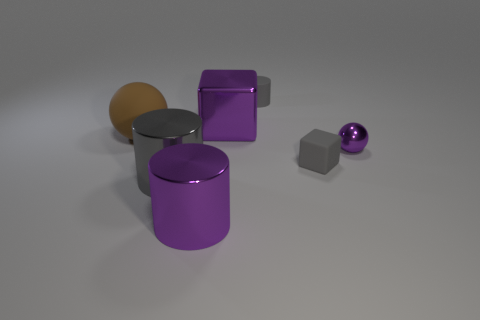What could be the practical function of these objects if they were real? If these objects were real, their functions could vary. The cylinders and cube could serve as storage containers or stylish furniture pieces like tables or stools. The small sphere could be a decorative element or a paperweight. The textures suggest perhaps a home or office environment where aesthetics are as important as utility. 